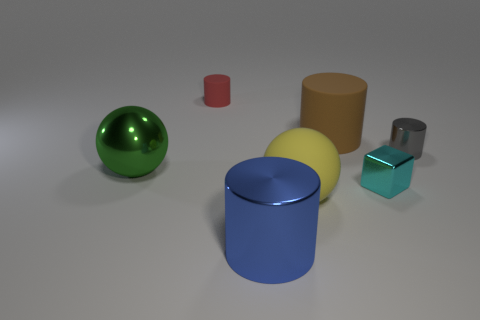Are the big thing to the left of the large blue metallic object and the big cylinder in front of the large yellow sphere made of the same material?
Offer a very short reply. Yes. Is there anything else that has the same shape as the cyan object?
Ensure brevity in your answer.  No. What is the color of the large metal cylinder?
Your answer should be very brief. Blue. What number of gray objects are the same shape as the green metallic thing?
Keep it short and to the point. 0. There is another metallic object that is the same size as the green object; what is its color?
Provide a succinct answer. Blue. Are any small red cylinders visible?
Ensure brevity in your answer.  Yes. What is the shape of the big metallic object that is in front of the yellow sphere?
Your response must be concise. Cylinder. What number of things are to the right of the small red rubber cylinder and in front of the brown matte cylinder?
Make the answer very short. 4. Is there a large gray cylinder that has the same material as the cyan object?
Offer a very short reply. No. What number of balls are small red matte things or blue things?
Offer a terse response. 0. 